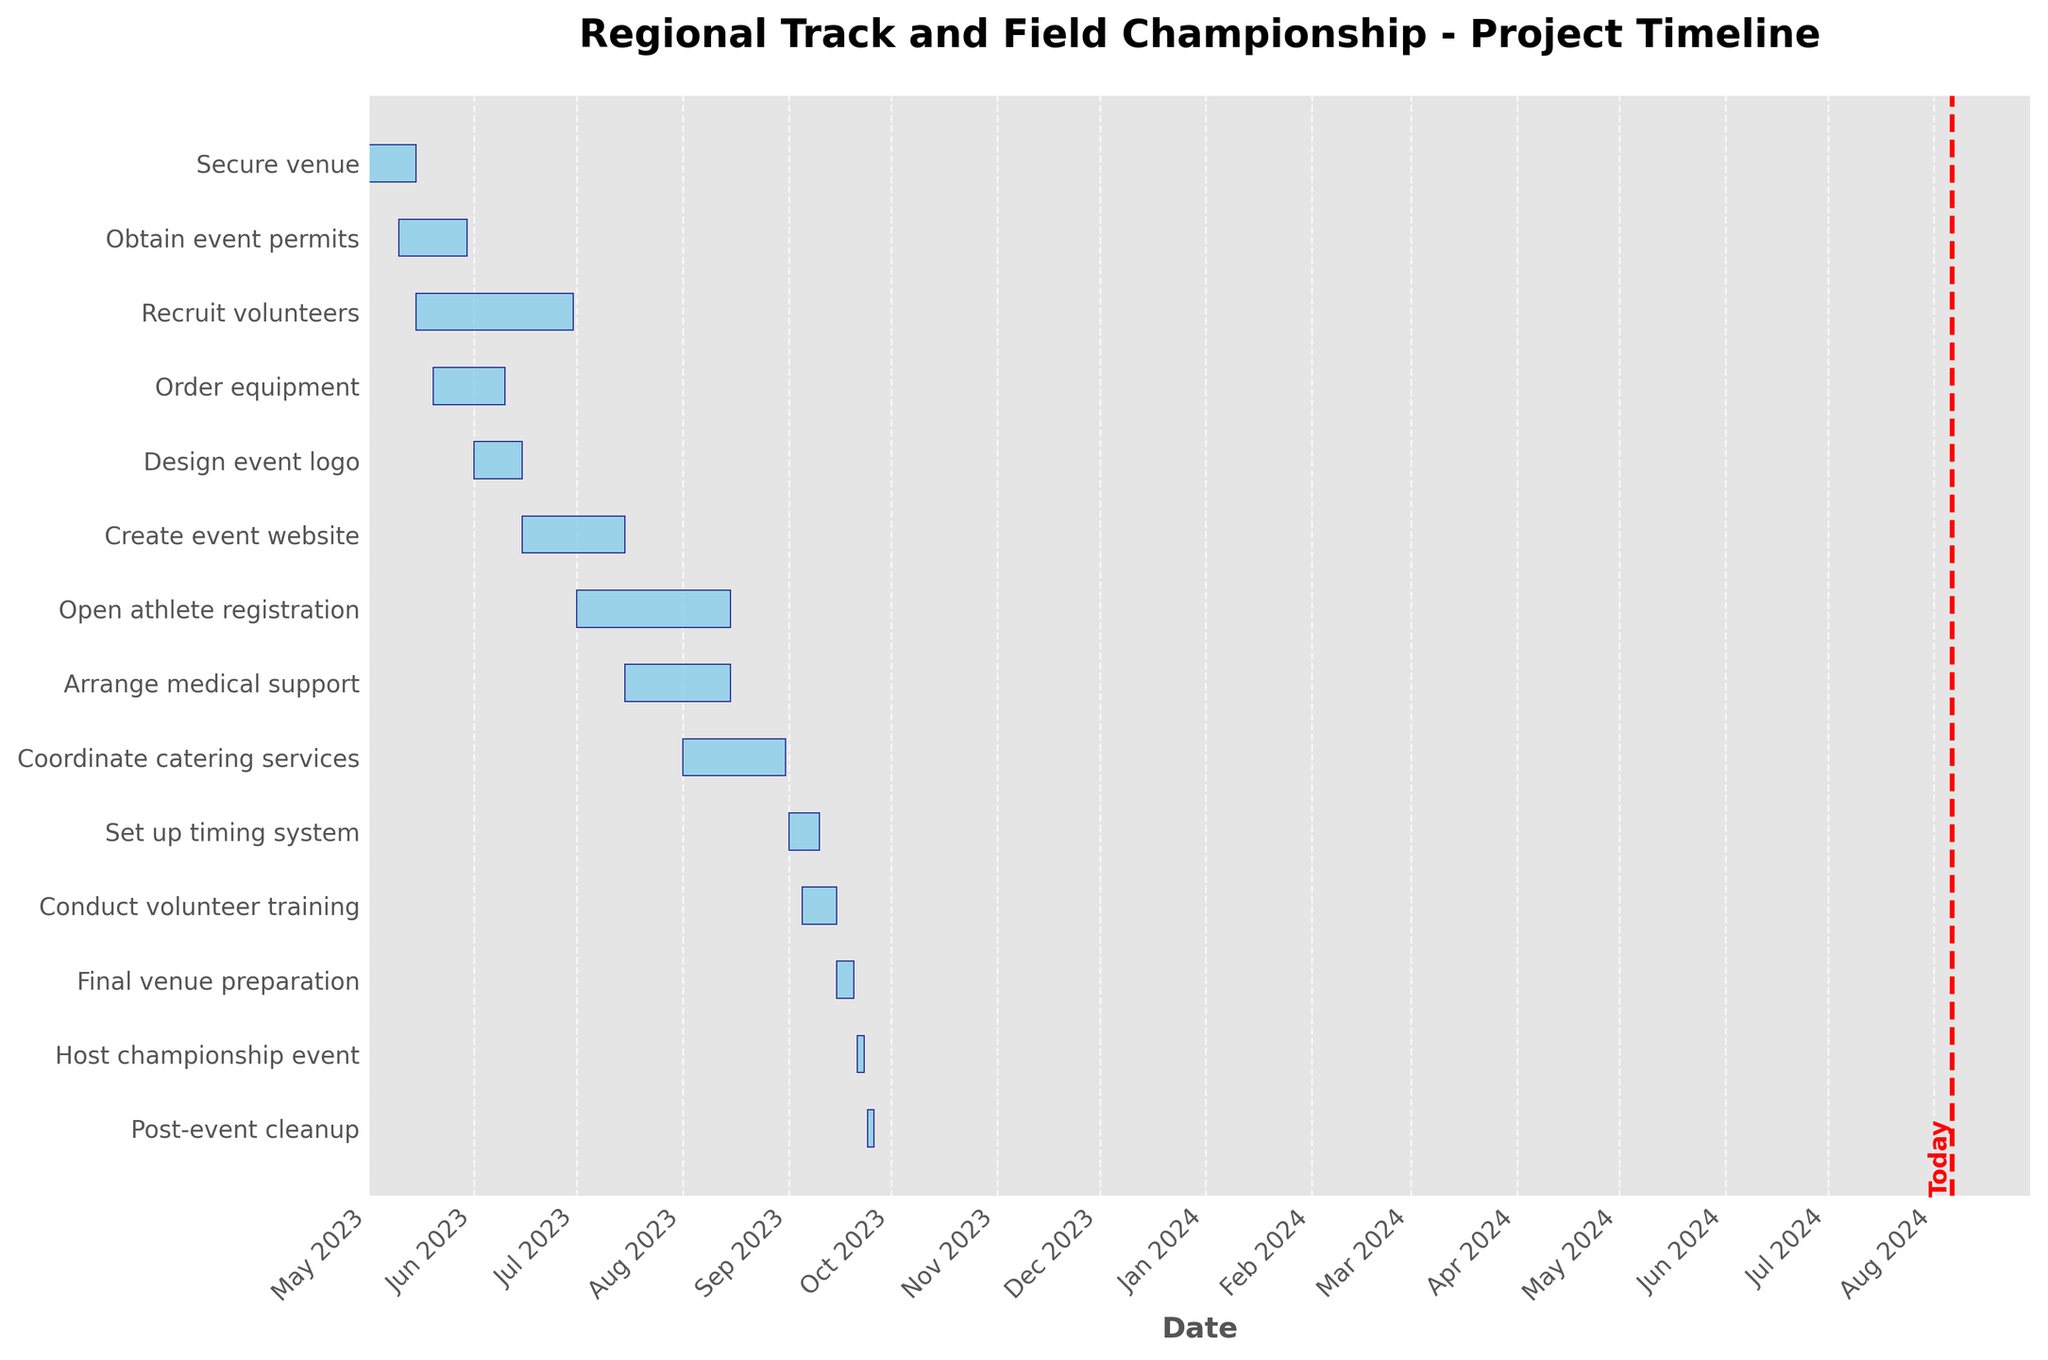What's the title of the figure? The title of the figure is found at the top center of the chart. By reading this title, we gain an understanding of what the Gantt Chart is representing.
Answer: Regional Track and Field Championship - Project Timeline Which task starts first according to the timeline? The task that starts first can be identified by looking at the leftmost bar on the Gantt Chart, representing the earliest starting date.
Answer: Secure venue Which task spans the longest duration in days? We can determine this by finding the longest horizontal bar on the Gantt Chart. By visually comparing the lengths of all bars, the longest one represents the task with the longest duration.
Answer: Recruit volunteers Are there any tasks that end on the same date? To find tasks that end on the same date, we need to look for bars that terminate at the same point horizontally. In this case, these tasks will align vertically at their endpoints.
Answer: Arrange medical support and Open athlete registration How many days in total from the first task until the post-event cleanup? Calculate the total days by subtracting the start date of the first task from the end date of the last task. The first task (Secure venue) starts on 2023-05-01, and the last task (Post-event cleanup) ends on 2023-09-26. Total days = 2023-09-26 - 2023-05-01.
Answer: 149 days Which task overlaps with the "Order equipment" task the most? Identify the task that has the most significant overlapping duration with "Order equipment" by visually examining the chart. "Order equipment" runs from 2023-05-20 to 2023-06-10. Compare these dates with other tasks to see which has the most overlap.
Answer: Recruit volunteers When does the "Final venue preparation" task start relative to the date line indicating today? Locate the "Final venue preparation" task and the red date line indicating today. Determine whether "Final venue preparation" is scheduled to start before or after today's date.
Answer: After today's date Which task has the shortest duration? Look for the shortest horizontal bar on the Gantt Chart, as this bar represents the task with the shortest duration.
Answer: Post-event cleanup How many tasks begin in July? Count the number of bars that start within the month of July by locating their start dates on the x-axis. Look for the bars’ left edges that align with July 2023.
Answer: 3 tasks What tasks need to be completed before the "Set up timing system"? Find the "Set up timing system" task and identify all preceding tasks by their order in the timeline. Look at the bars that end before the "Set up timing system" starts on 2023-09-01.
Answer: All tasks before "Set up timing system" in the timeline order, such as "Secure venue," "Obtain event permits," etc 